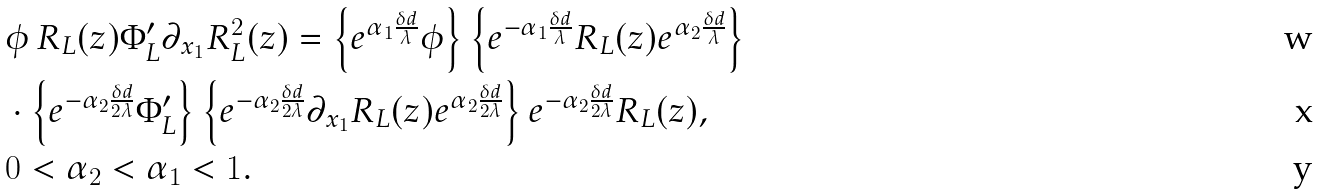<formula> <loc_0><loc_0><loc_500><loc_500>& \phi \, R _ { L } ( z ) \Phi _ { L } ^ { \prime } \partial _ { x _ { 1 } } R _ { L } ^ { 2 } ( z ) = \left \{ e ^ { \alpha _ { 1 } \frac { \delta d } { \lambda } } \phi \right \} \left \{ e ^ { - \alpha _ { 1 } \frac { \delta d } { \lambda } } R _ { L } ( z ) e ^ { \alpha _ { 2 } \frac { \delta d } { \lambda } } \right \} \\ & \cdot \left \{ e ^ { - \alpha _ { 2 } \frac { \delta d } { 2 \lambda } } \Phi _ { L } ^ { \prime } \right \} \left \{ e ^ { - \alpha _ { 2 } \frac { \delta d } { 2 \lambda } } \partial _ { x _ { 1 } } R _ { L } ( z ) e ^ { \alpha _ { 2 } \frac { \delta d } { 2 \lambda } } \right \} e ^ { - \alpha _ { 2 } \frac { \delta d } { 2 \lambda } } R _ { L } ( z ) , \\ & 0 < \alpha _ { 2 } < \alpha _ { 1 } < 1 .</formula> 